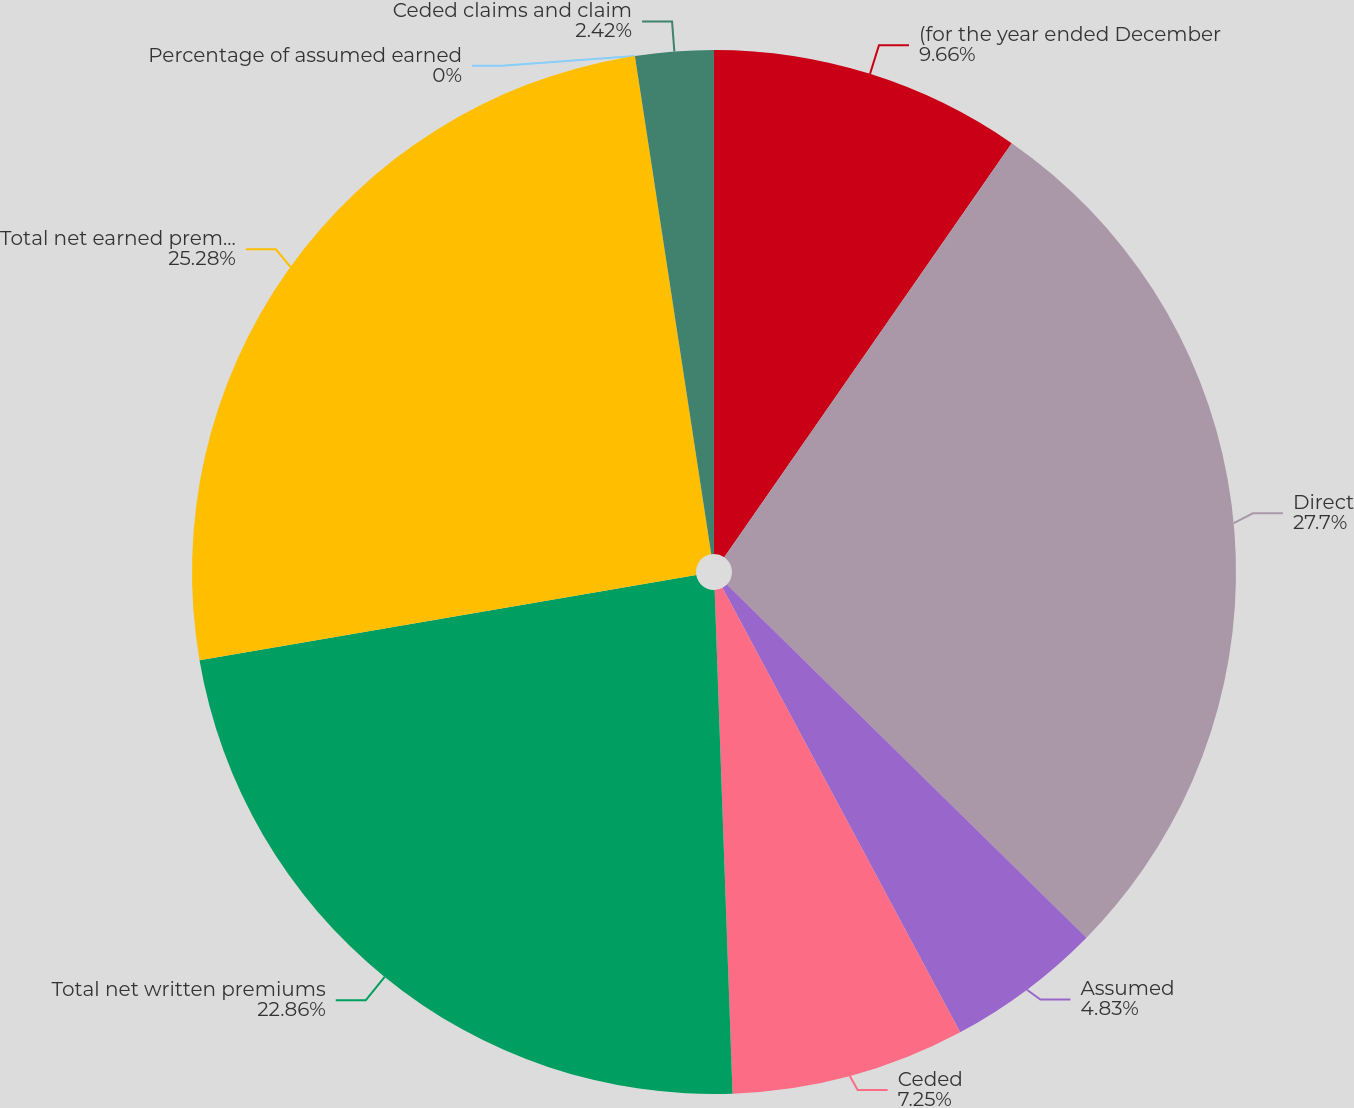Convert chart. <chart><loc_0><loc_0><loc_500><loc_500><pie_chart><fcel>(for the year ended December<fcel>Direct<fcel>Assumed<fcel>Ceded<fcel>Total net written premiums<fcel>Total net earned premiums<fcel>Percentage of assumed earned<fcel>Ceded claims and claim<nl><fcel>9.66%<fcel>27.69%<fcel>4.83%<fcel>7.25%<fcel>22.86%<fcel>25.28%<fcel>0.0%<fcel>2.42%<nl></chart> 